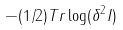<formula> <loc_0><loc_0><loc_500><loc_500>- ( 1 / 2 ) T r \log ( \delta ^ { 2 } I )</formula> 